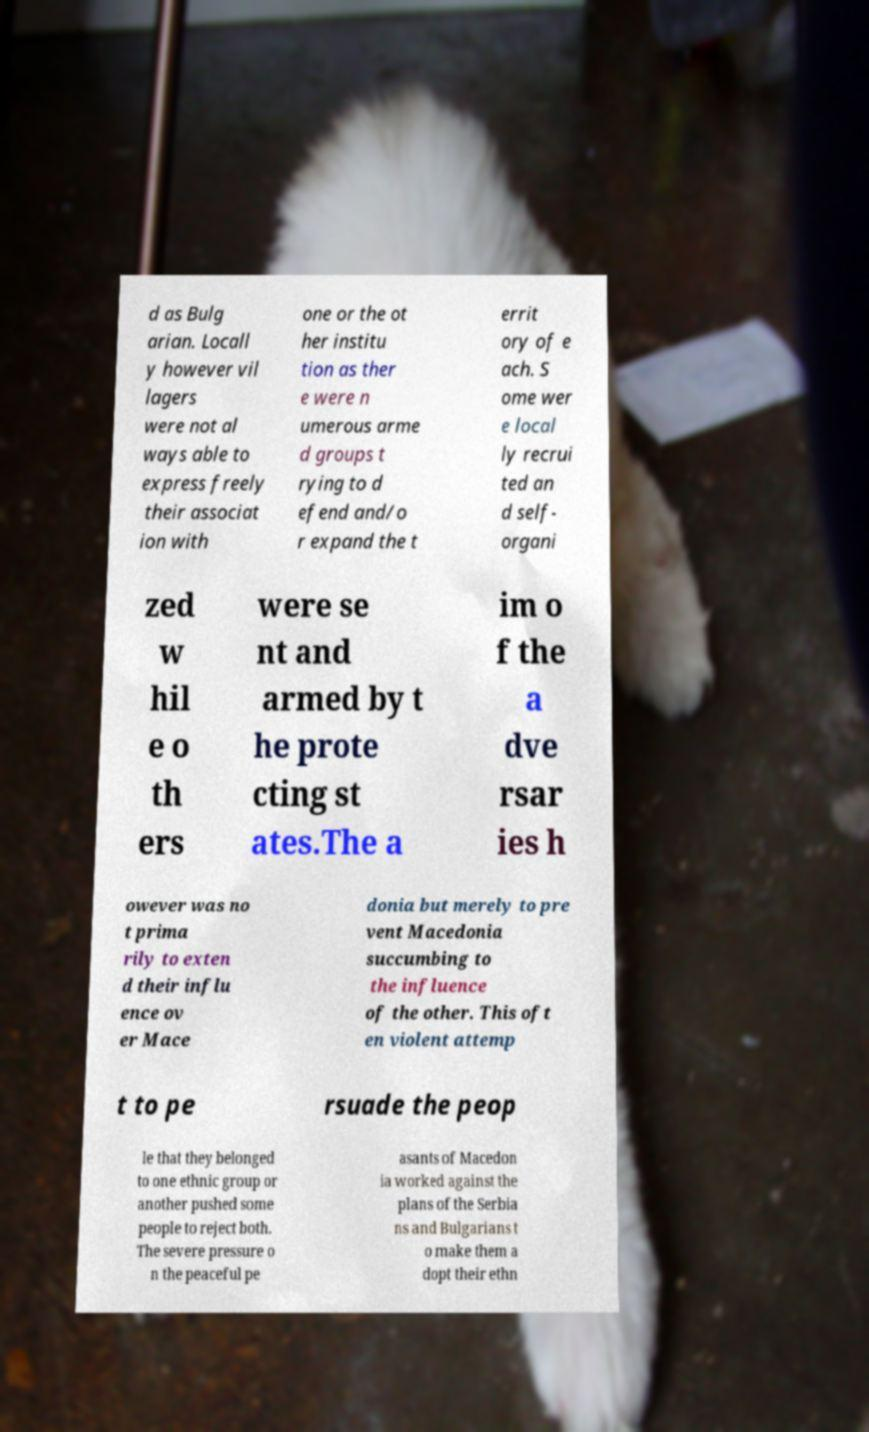What messages or text are displayed in this image? I need them in a readable, typed format. d as Bulg arian. Locall y however vil lagers were not al ways able to express freely their associat ion with one or the ot her institu tion as ther e were n umerous arme d groups t rying to d efend and/o r expand the t errit ory of e ach. S ome wer e local ly recrui ted an d self- organi zed w hil e o th ers were se nt and armed by t he prote cting st ates.The a im o f the a dve rsar ies h owever was no t prima rily to exten d their influ ence ov er Mace donia but merely to pre vent Macedonia succumbing to the influence of the other. This oft en violent attemp t to pe rsuade the peop le that they belonged to one ethnic group or another pushed some people to reject both. The severe pressure o n the peaceful pe asants of Macedon ia worked against the plans of the Serbia ns and Bulgarians t o make them a dopt their ethn 